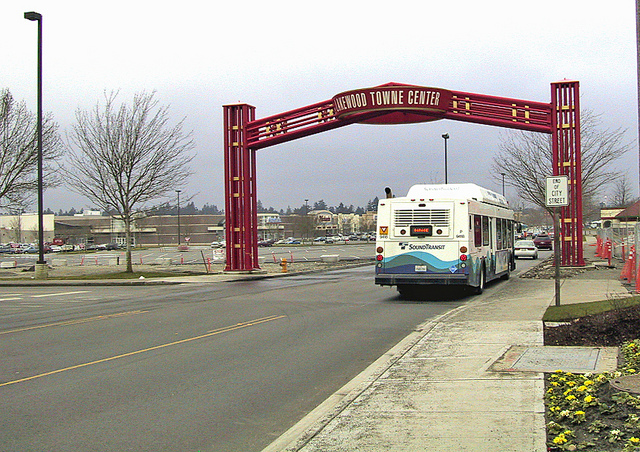Identify and read out the text in this image. WOOD TOWNE CENTER CITY STREET OF 